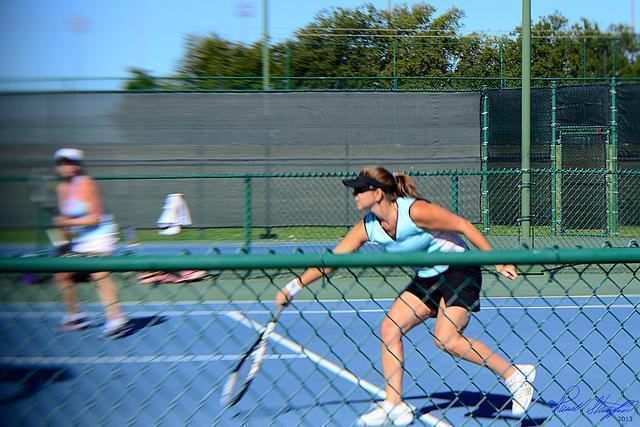What surface are they playing on?
Indicate the correct response and explain using: 'Answer: answer
Rationale: rationale.'
Options: Grass, clay, indoor hard, outdoor hard. Answer: outdoor hard.
Rationale: They are playing on an outdoor tennis court. 